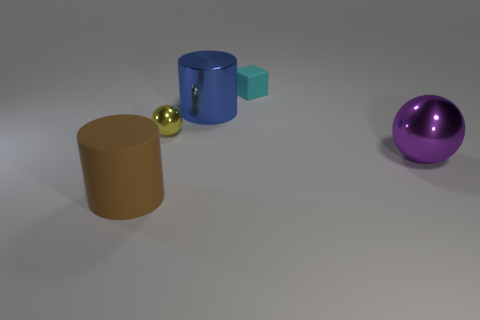Add 2 small cyan matte things. How many objects exist? 7 Subtract all balls. How many objects are left? 3 Subtract all big shiny things. Subtract all blue metal objects. How many objects are left? 2 Add 1 tiny cyan rubber cubes. How many tiny cyan rubber cubes are left? 2 Add 4 purple metal balls. How many purple metal balls exist? 5 Subtract 1 brown cylinders. How many objects are left? 4 Subtract all blue cubes. Subtract all cyan cylinders. How many cubes are left? 1 